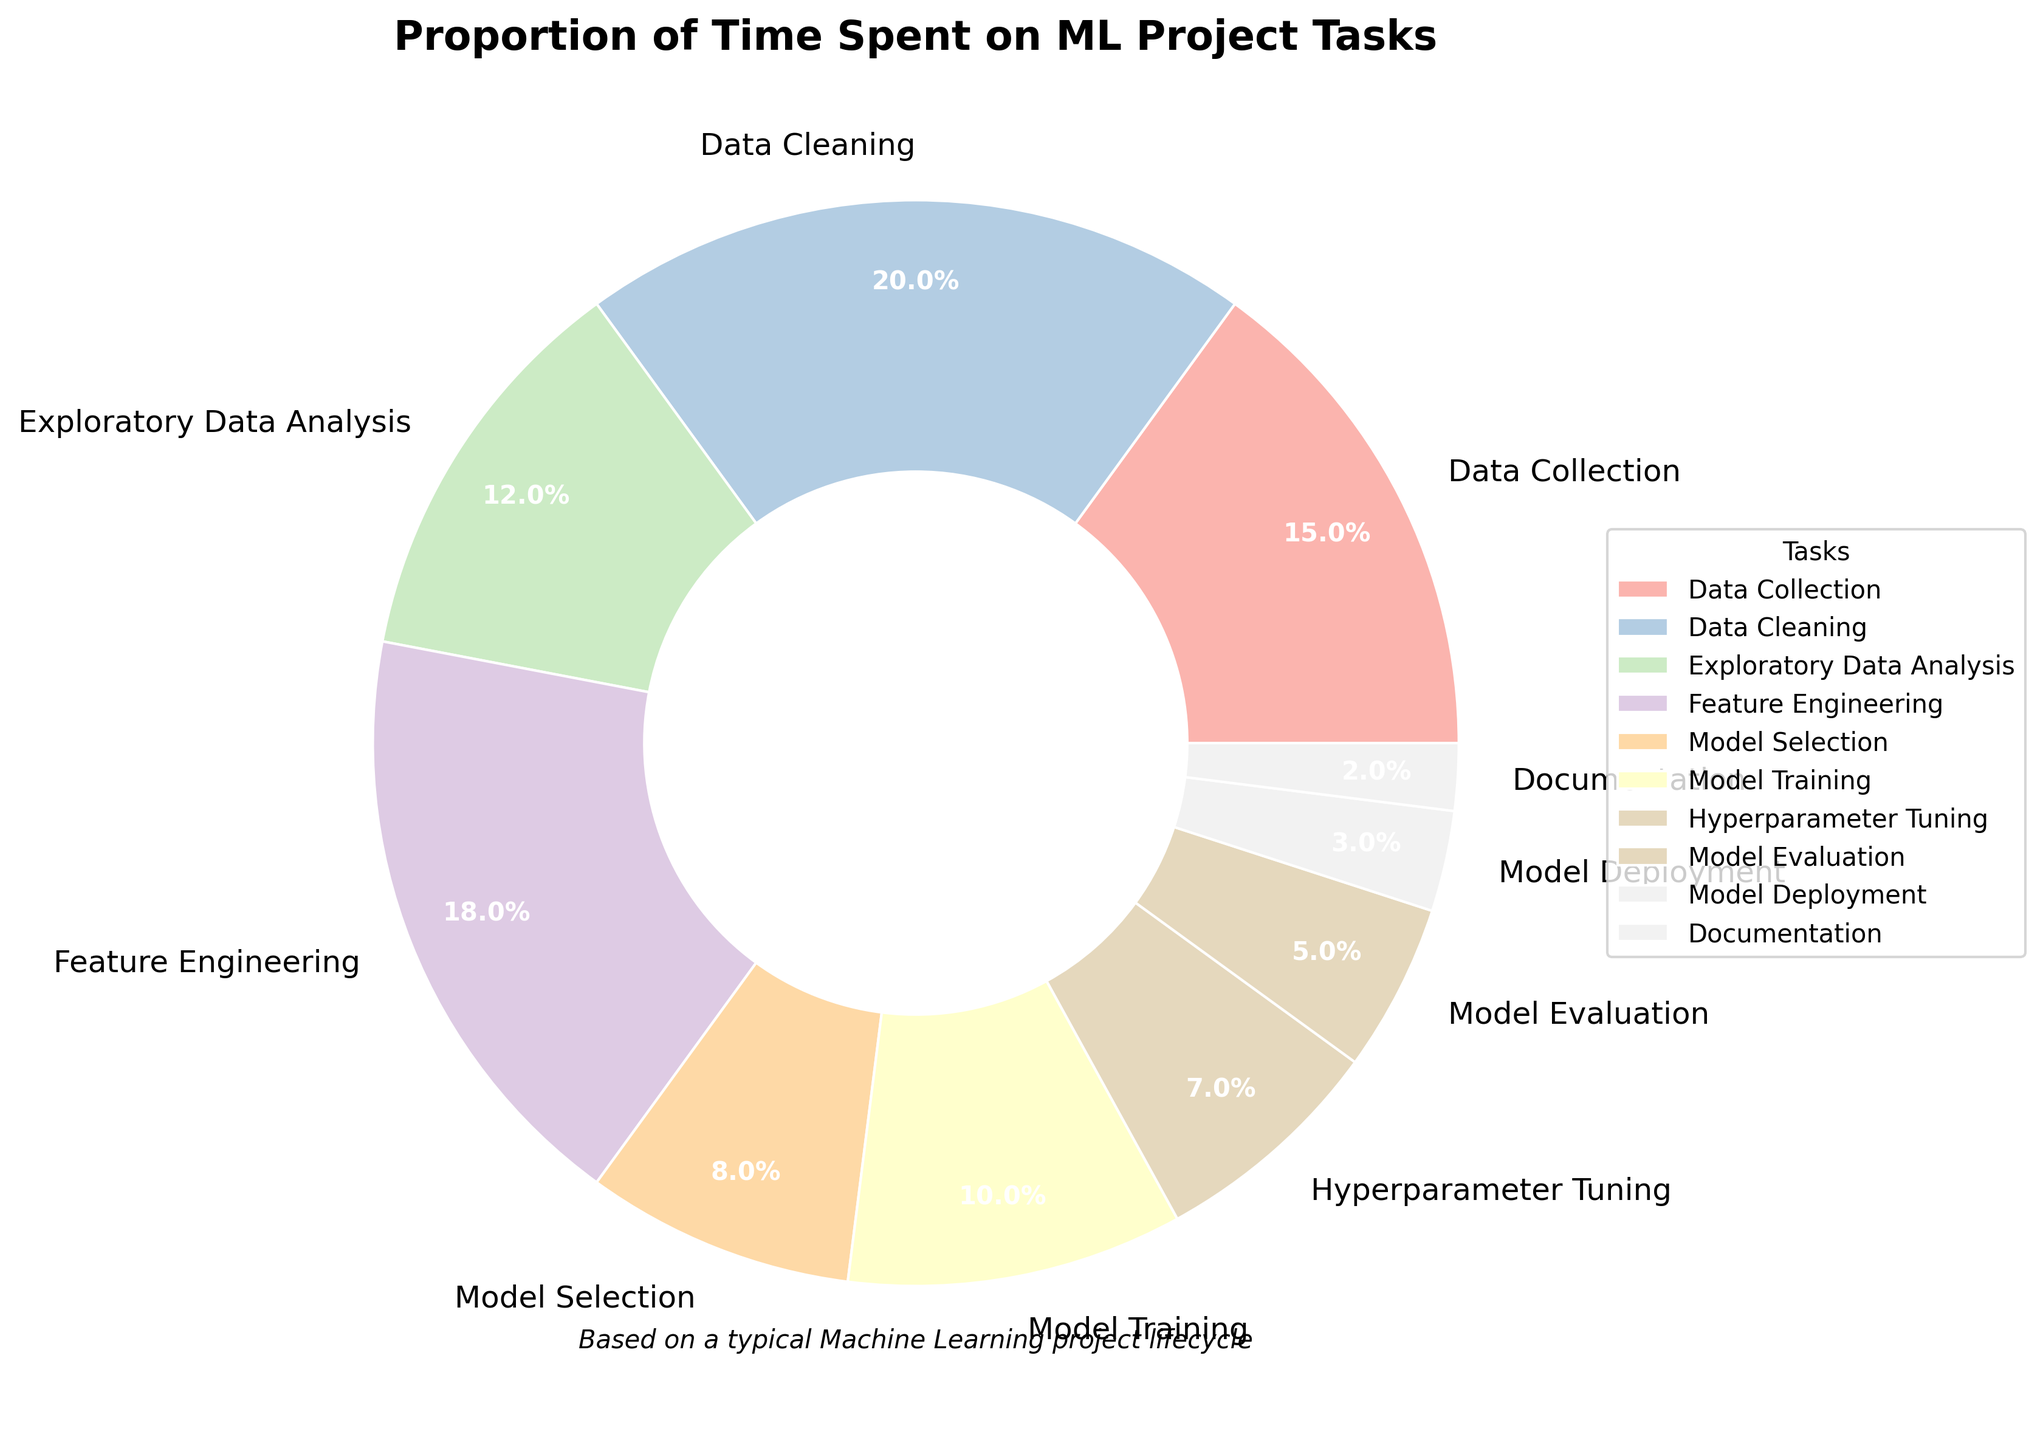Which task takes the largest percentage of time? By observing the pie chart, it's clear which segment is the largest and has the highest percentage labeled.
Answer: Data Cleaning (20%) Which tasks together take up equal time as Data Collection? Data Collection takes 15%, so look for segments whose percentages add up to 15%, like Model Selection (8%) and Documentation (7%) combined.
Answer: Model Selection and Documentation Which two tasks combined have the same total percentage as Feature Engineering? Feature Engineering is 18%. Identify tasks summing up to 18%, like Data Collection (15%) and Model Deployment (3%).
Answer: Data Collection and Model Deployment What is the difference between the time spent on Hyperparameter Tuning and Model Evaluation? Hyperparameter Tuning is 7% and Model Evaluation is 5%, the difference is calculated as 7% - 5%.
Answer: 2% What's the combined percentage of time spent on Model-related tasks (Selection, Training, Tuning, Evaluation, Deployment)? Sum the percentages for Model Selection (8%), Model Training (10%), Hyperparameter Tuning (7%), Model Evaluation (5%), and Model Deployment (3%). The total is 8% + 10% + 7% + 5% + 3% = 33%.
Answer: 33% Which task takes the least percentage of time? Look for the smallest segment in the pie chart and its label.
Answer: Documentation (2%) Which tasks require more time than Model Training? Model Training is 10%. Identify tasks with percentages greater than 10%. These are Data Collection (15%), Data Cleaning (20%), and Feature Engineering (18%).
Answer: Data Collection, Data Cleaning, Feature Engineering What is the total percentage of time spent on Data-related tasks (Collection, Cleaning, and EDA)? Sum the percentages for Data Collection (15%), Data Cleaning (20%), and Exploratory Data Analysis (12%): 15% + 20% + 12% = 47%.
Answer: 47% How much more time is spent on Data Cleaning compared to Documentation? Data Cleaning is 20% and Documentation is 2%. Find the difference: 20% - 2% = 18%.
Answer: 18% Among the model-related tasks, which takes the least amount of time? Look at the model-related tasks (Selection, Training, Tuning, Evaluation, Deployment) and find the smallest percentage. Model Deployment is 3%, which is the lowest.
Answer: Model Deployment (3%) 